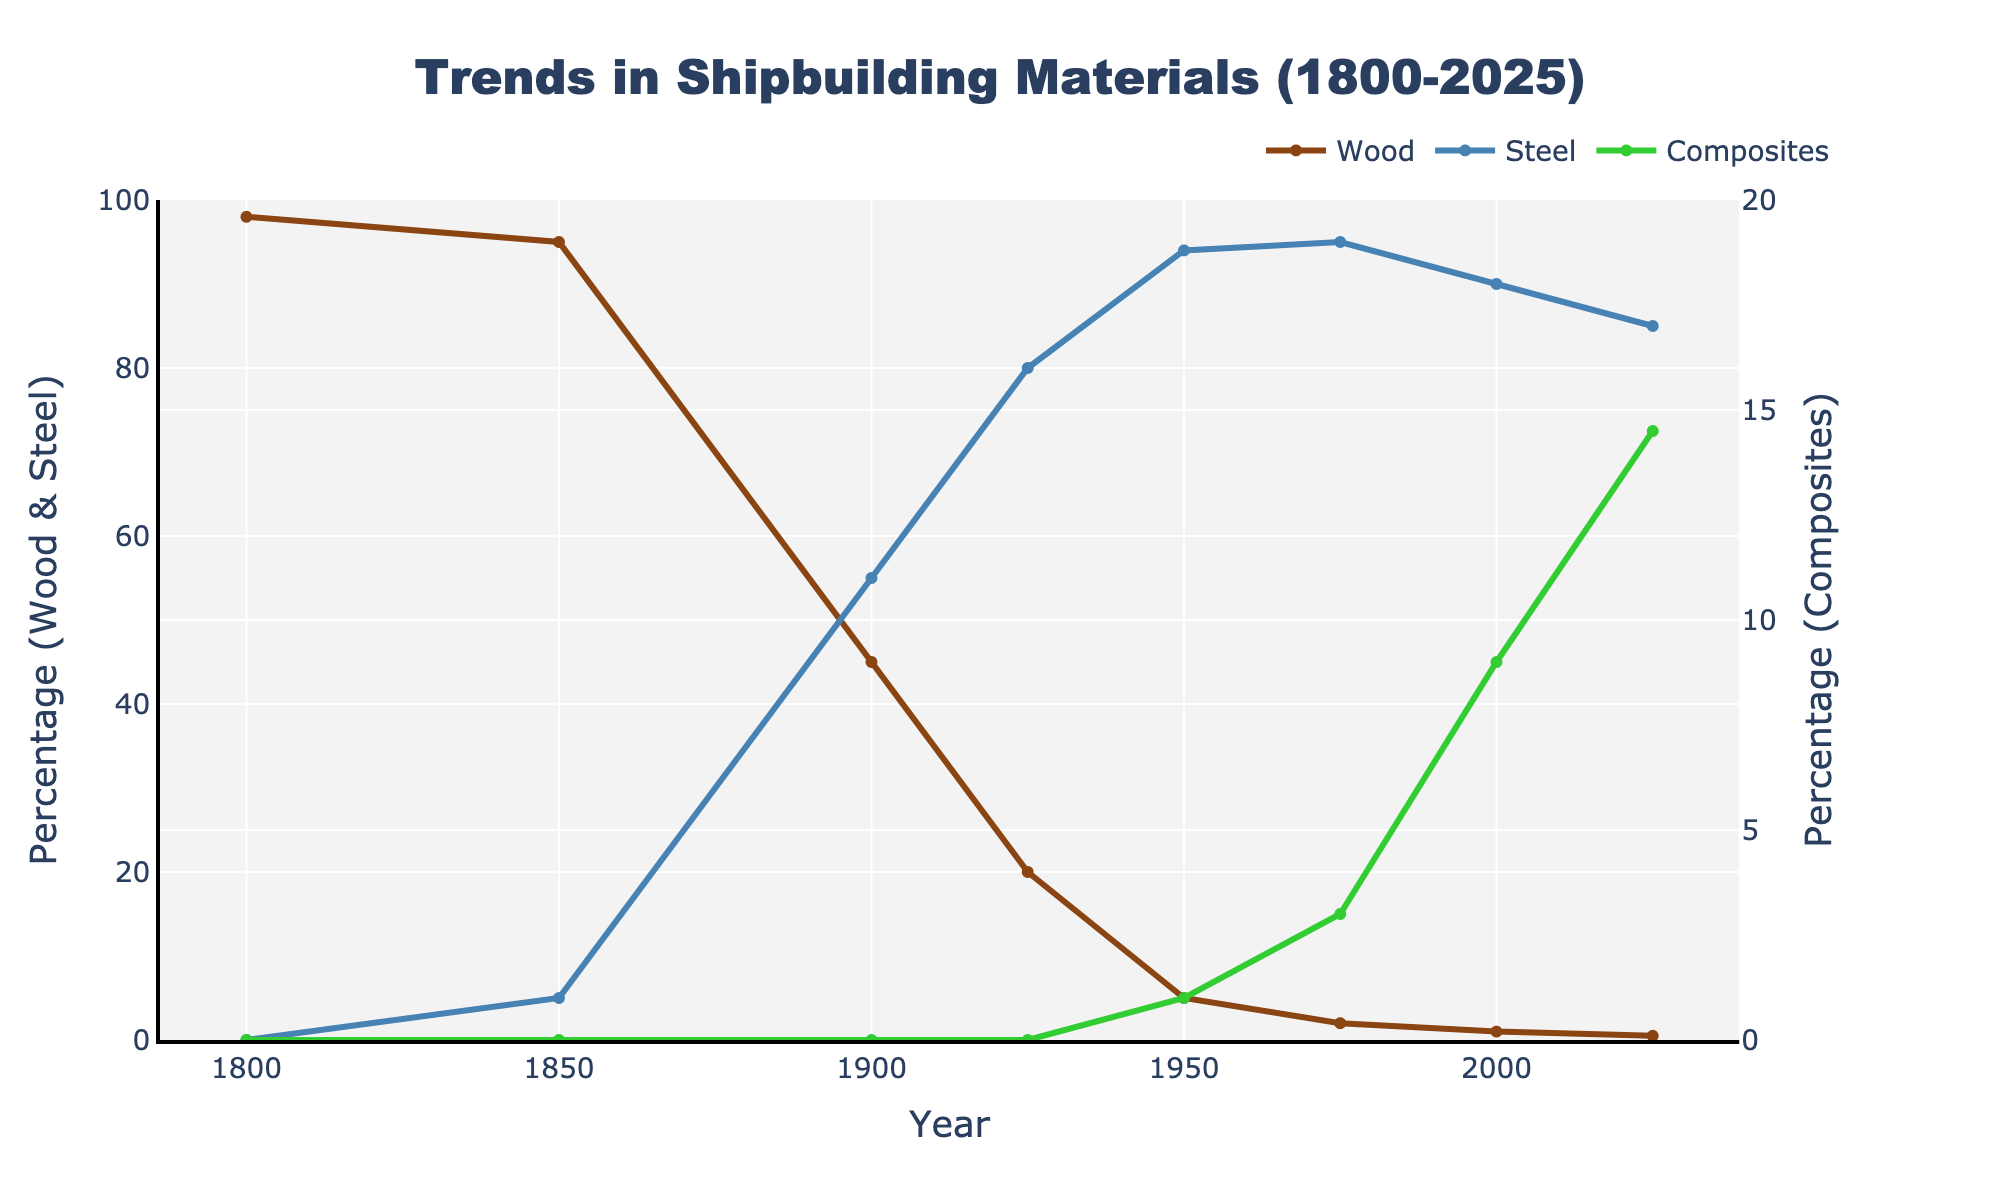When did the use of wood in shipbuilding drop below 50%? The use of wood in shipbuilding dropped below 50% between 1850 and 1900. Observing the figures, in 1850, the percentage of wood was 95%, and in 1900, it was 45%.
Answer: Between 1850 and 1900 What year had the highest percentage use of steel in shipbuilding? By referring to the figure, the highest percentage of steel usage is in 1975, where it peaked at 95%.
Answer: 1975 How do the trends in the use of steel and composites compare between 1950 and 2025? The trends show that the percentage of steel slightly decreases from 94% in 1950 to 85% in 2025, while the composites increase from 1% in 1950 to 14.5% in 2025.
Answer: Steel decreases, composites increase What is the difference in the percentage use of wood between 1800 and 2025? The percentage use of wood in 1800 was 98%, and in 2025, it's 0.5%. Subtracting these values gives 98 - 0.5 = 97.5%.
Answer: 97.5% Which material saw the least variation in usage percentage over the years? From the figure, composites show the least variation, gradually increasing from 0 in 1800 to approximately 14.5% in 2025. Both wood and steel exhibit significant declines and increases, respectively.
Answer: Composites At what rate did the use of wood decline from 1800 to 2000? The use of wood declined from 98% in 1800 to 1% in 2000. To find the rate, we calculate the difference (98 - 1 = 97) and divide it by the number of years (2000 - 1800 = 200), giving a decline rate of 97 / 200 = 0.485% per year.
Answer: 0.485% per year In which year did composites begin to be used in shipbuilding, according to the figure? Composites appear to be used from 1950 onwards, as indicated by a small percentage (1%) in that year.
Answer: 1950 What is the aggregate percentage change of steel between 1900 and 1975? The percentage of steel usage in 1900 is 55%, and by 1975 it has increased to 95%. The aggregate change is calculated as 95 - 55 = 40%.
Answer: 40% If you compare the use of wood in 1900 and 1925, how much did it decrease by? The use of wood in shipbuilding in 1900 was 45%, and in 1925 it was 20%. The decrease can be calculated by taking the difference: 45 - 20 = 25%.
Answer: 25% What does the secondary y-axis represent in the figure? The secondary y-axis represents the percentage use of composites in shipbuilding.
Answer: Percentage use of composites 